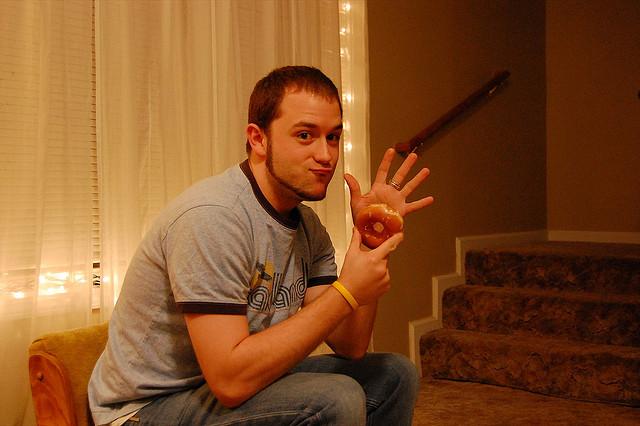What is the man holding?
Write a very short answer. Donut. What is on the man's chin?
Short answer required. Beard. What is the young man looking at?
Be succinct. Camera. Are the blinds open or closed?
Give a very brief answer. Closed. Are there stairs in the photo?
Give a very brief answer. Yes. 